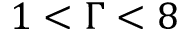Convert formula to latex. <formula><loc_0><loc_0><loc_500><loc_500>1 < \Gamma < 8</formula> 